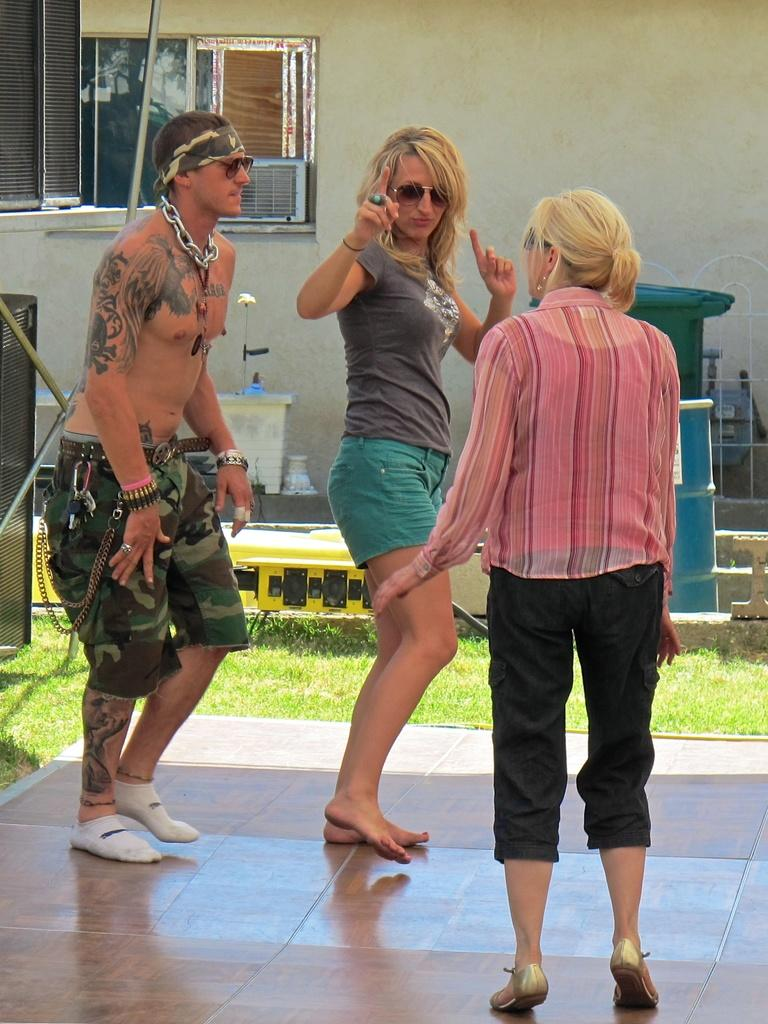How many people are present in the image? There are three persons standing in the image. What is located beside the persons? There is greenery grass beside the persons. What can be seen in the background of the image? There is an air conditioner and other objects visible in the background of the image. What type of fish can be seen swimming in the image? There are no fish present in the image; it features three persons standing near greenery grass and an air conditioner in the background. What is the size of the chin of the person on the left in the image? The image does not provide enough detail to determine the size of the chin of the person on the left. 